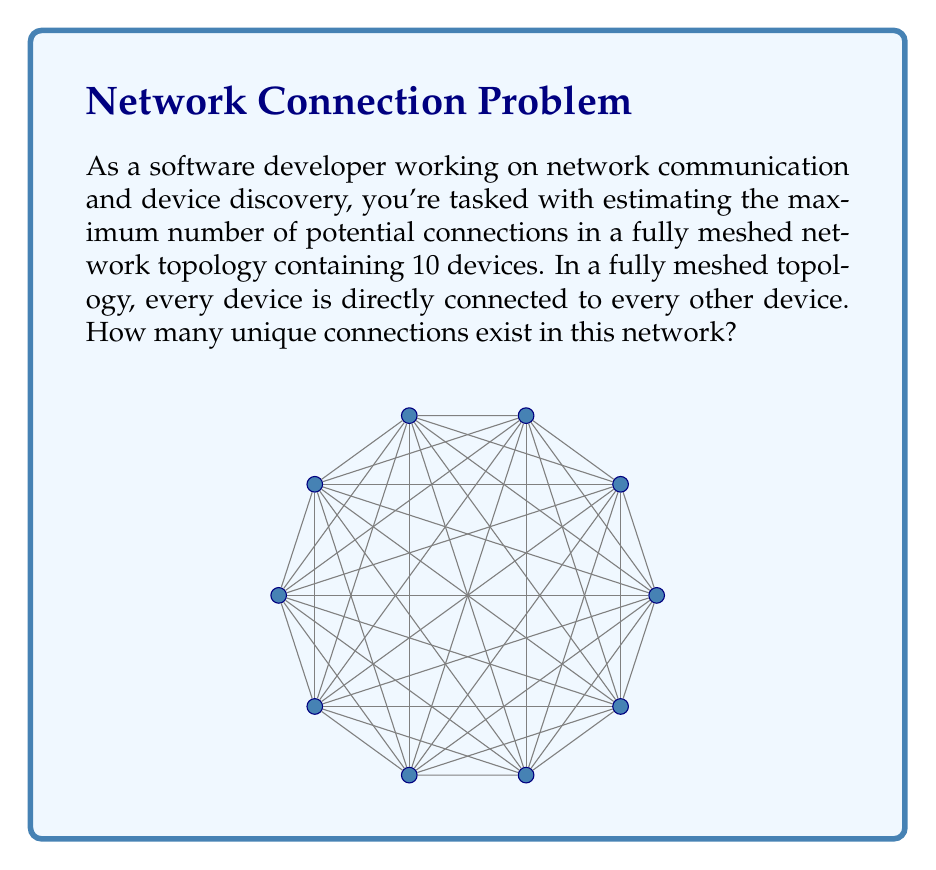Help me with this question. To solve this problem, we need to use combinatorics. Specifically, we'll use the combination formula to calculate the number of unique pairs of devices.

1. In a fully meshed network, each device connects to every other device exactly once.
2. We need to choose 2 devices out of 10 for each connection.
3. The order of selection doesn't matter (device A to B is the same as B to A).
4. This scenario is perfectly suited for the combination formula: $C(n,r) = \frac{n!}{r!(n-r)!}$

Where:
- $n$ is the total number of devices (10 in this case)
- $r$ is the number of devices we're selecting for each connection (2)

Let's plug in the numbers:

$$C(10,2) = \frac{10!}{2!(10-2)!} = \frac{10!}{2!(8)!}$$

Expanding this:
$$\frac{10 \cdot 9 \cdot 8!}{2 \cdot 1 \cdot 8!}$$

The 8! cancels out in the numerator and denominator:

$$\frac{10 \cdot 9}{2 \cdot 1} = \frac{90}{2} = 45$$

Therefore, in a fully meshed network with 10 devices, there are 45 unique connections.
Answer: 45 connections 